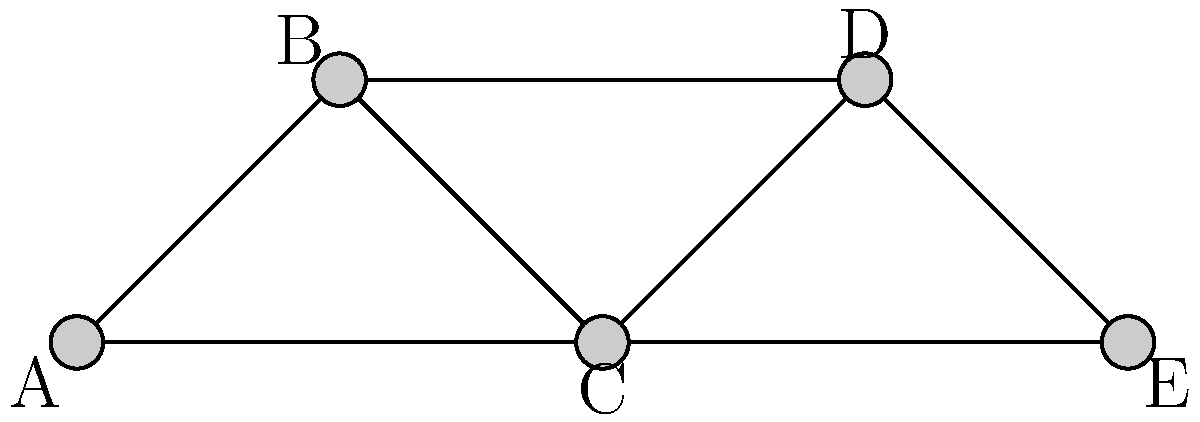In this social network graph of fashion influencers, where nodes represent influencers and edges represent collaborations, which influencer has the highest degree centrality and is likely to have the most connections with top designers? To determine the influencer with the highest degree centrality, we need to count the number of edges connected to each node:

1. Node A: 2 edges
2. Node B: 2 edges
3. Node C: 3 edges
4. Node D: 2 edges
5. Node E: 2 edges

The degree centrality is a measure of the number of direct connections a node has in a network. In this case, Node C has the highest degree centrality with 3 connections.

A higher degree centrality suggests that the influencer represented by Node C has collaborated with more people in the network. This increased connectivity implies a greater likelihood of having connections with top designers, as they have more opportunities for interaction and collaboration within the fashion industry.
Answer: C 